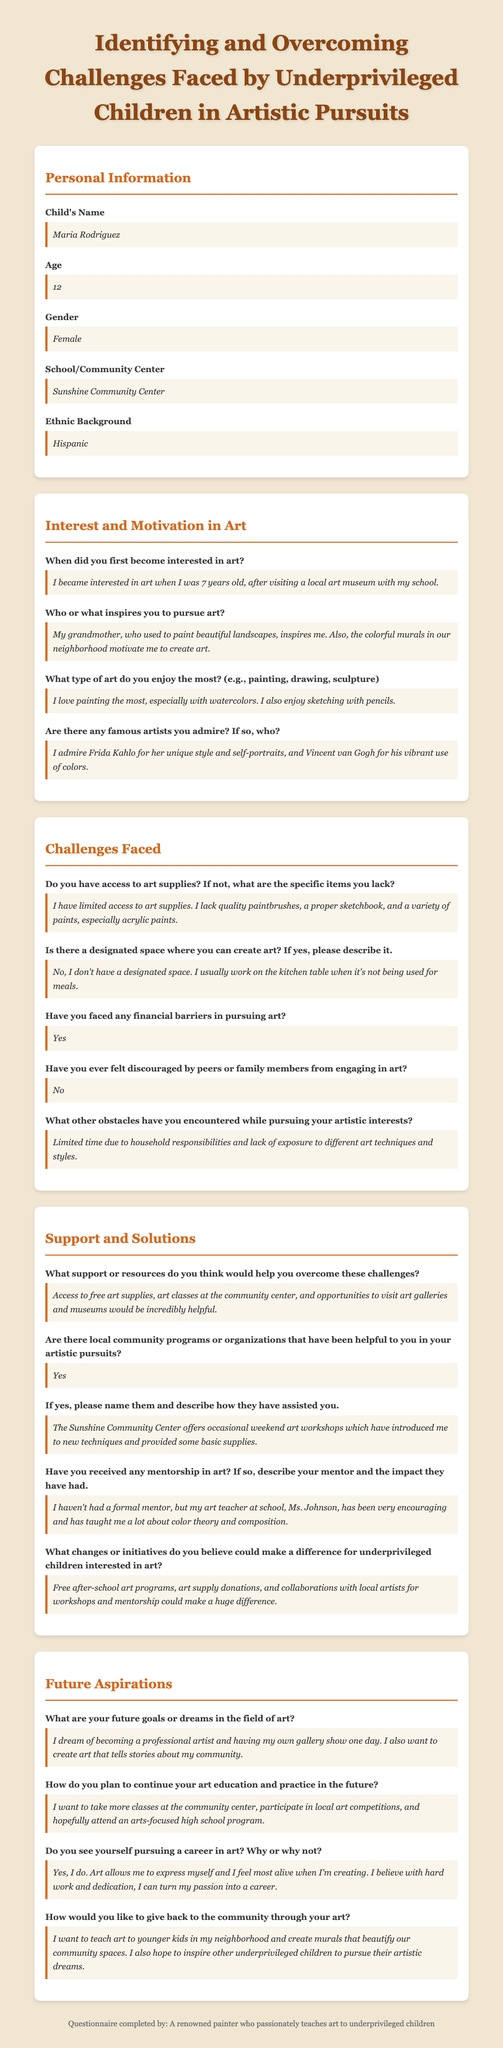What is the child's name? The child's name is clearly stated in the personal information section of the document.
Answer: Maria Rodriguez How old is Maria? Maria's age is provided directly in the document under the personal information section.
Answer: 12 What type of art does Maria enjoy the most? Maria's favorite type of art is specified in the interest and motivation section of the document.
Answer: Painting What challenges does Maria face regarding art supplies? Maria's challenge with art supplies is detailed in the challenges faced section of the document.
Answer: Limited access to art supplies What support does Maria believe would help her overcome challenges? Maria mentions the support she needs in the support and solutions section of the document.
Answer: Access to free art supplies Has Maria faced any financial barriers in pursuing art? The document specifies whether Maria has faced financial barriers in the challenges faced section.
Answer: Yes What is one of Maria's future goals in art? Maria's future aspirations are outlined in the future aspirations section of the document.
Answer: Becoming a professional artist What local community program has been helpful to Maria? The document describes a local community program that has aided Maria in her artistic pursuits.
Answer: Sunshine Community Center Who inspires Maria to pursue art? The inspiration for Maria's art is mentioned in the interest and motivation section of the document.
Answer: Her grandmother 